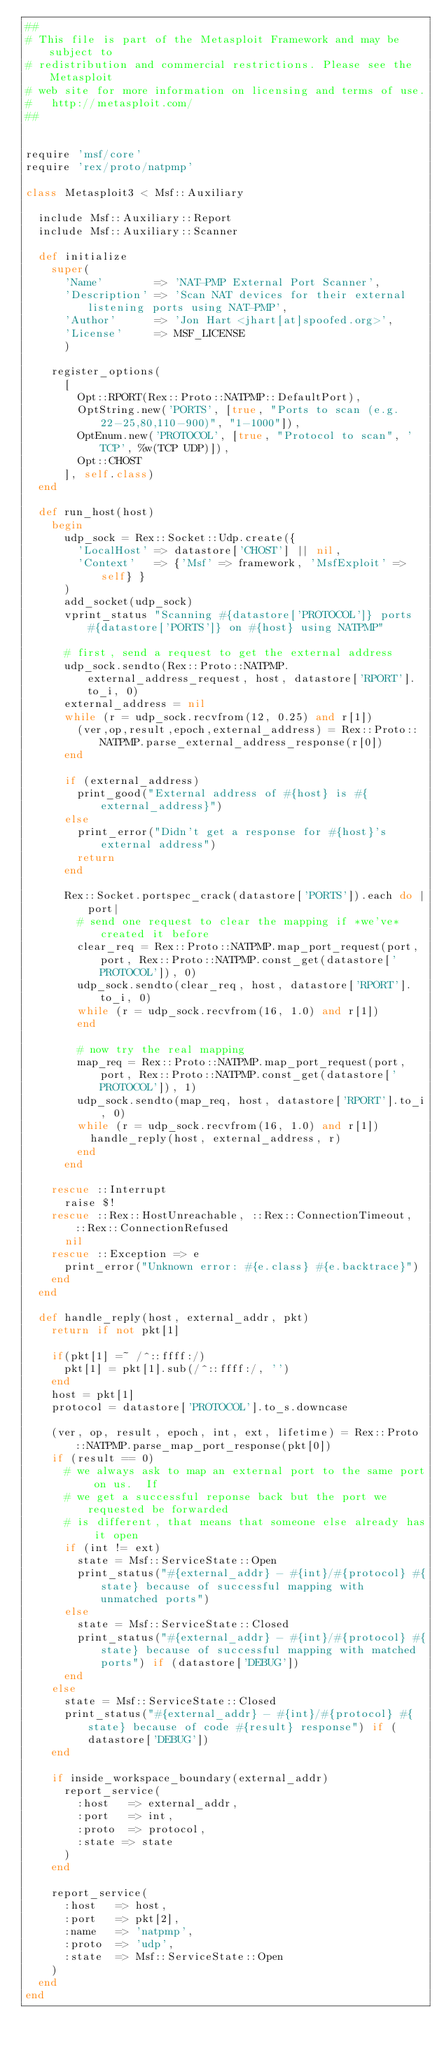Convert code to text. <code><loc_0><loc_0><loc_500><loc_500><_Ruby_>##
# This file is part of the Metasploit Framework and may be subject to
# redistribution and commercial restrictions. Please see the Metasploit
# web site for more information on licensing and terms of use.
#   http://metasploit.com/
##


require 'msf/core'
require 'rex/proto/natpmp'

class Metasploit3 < Msf::Auxiliary

	include Msf::Auxiliary::Report
	include Msf::Auxiliary::Scanner

	def initialize
		super(
			'Name'        => 'NAT-PMP External Port Scanner',
			'Description' => 'Scan NAT devices for their external listening ports using NAT-PMP',
			'Author'      => 'Jon Hart <jhart[at]spoofed.org>',
			'License'     => MSF_LICENSE
			)

		register_options(
			[
				Opt::RPORT(Rex::Proto::NATPMP::DefaultPort),
				OptString.new('PORTS', [true, "Ports to scan (e.g. 22-25,80,110-900)", "1-1000"]),
				OptEnum.new('PROTOCOL', [true, "Protocol to scan", 'TCP', %w(TCP UDP)]),
				Opt::CHOST
			], self.class)
	end

	def run_host(host)
		begin
			udp_sock = Rex::Socket::Udp.create({
				'LocalHost' => datastore['CHOST'] || nil,
				'Context'   => {'Msf' => framework, 'MsfExploit' => self} }
			)
			add_socket(udp_sock)
			vprint_status "Scanning #{datastore['PROTOCOL']} ports #{datastore['PORTS']} on #{host} using NATPMP"

			# first, send a request to get the external address
			udp_sock.sendto(Rex::Proto::NATPMP.external_address_request, host, datastore['RPORT'].to_i, 0)
			external_address = nil
			while (r = udp_sock.recvfrom(12, 0.25) and r[1])
				(ver,op,result,epoch,external_address) = Rex::Proto::NATPMP.parse_external_address_response(r[0])
			end

			if (external_address)
				print_good("External address of #{host} is #{external_address}")
			else
				print_error("Didn't get a response for #{host}'s external address")
				return
			end

			Rex::Socket.portspec_crack(datastore['PORTS']).each do |port|
				# send one request to clear the mapping if *we've* created it before
				clear_req = Rex::Proto::NATPMP.map_port_request(port, port, Rex::Proto::NATPMP.const_get(datastore['PROTOCOL']), 0)
				udp_sock.sendto(clear_req, host, datastore['RPORT'].to_i, 0)
				while (r = udp_sock.recvfrom(16, 1.0) and r[1])
				end

				# now try the real mapping
				map_req = Rex::Proto::NATPMP.map_port_request(port, port, Rex::Proto::NATPMP.const_get(datastore['PROTOCOL']), 1)
				udp_sock.sendto(map_req, host, datastore['RPORT'].to_i, 0)
				while (r = udp_sock.recvfrom(16, 1.0) and r[1])
					handle_reply(host, external_address, r)
				end
			end

		rescue ::Interrupt
			raise $!
		rescue ::Rex::HostUnreachable, ::Rex::ConnectionTimeout, ::Rex::ConnectionRefused
			nil
		rescue ::Exception => e
			print_error("Unknown error: #{e.class} #{e.backtrace}")
		end
	end

	def handle_reply(host, external_addr, pkt)
		return if not pkt[1]

		if(pkt[1] =~ /^::ffff:/)
			pkt[1] = pkt[1].sub(/^::ffff:/, '')
		end
		host = pkt[1]
		protocol = datastore['PROTOCOL'].to_s.downcase

		(ver, op, result, epoch, int, ext, lifetime) = Rex::Proto::NATPMP.parse_map_port_response(pkt[0])
		if (result == 0)
			# we always ask to map an external port to the same port on us.  If
			# we get a successful reponse back but the port we requested be forwarded
			# is different, that means that someone else already has it open
			if (int != ext)
				state = Msf::ServiceState::Open
				print_status("#{external_addr} - #{int}/#{protocol} #{state} because of successful mapping with unmatched ports")
			else
				state = Msf::ServiceState::Closed
				print_status("#{external_addr} - #{int}/#{protocol} #{state} because of successful mapping with matched ports") if (datastore['DEBUG'])
			end
		else
			state = Msf::ServiceState::Closed
			print_status("#{external_addr} - #{int}/#{protocol} #{state} because of code #{result} response") if (datastore['DEBUG'])
		end

		if inside_workspace_boundary(external_addr)
			report_service(
				:host   => external_addr,
				:port   => int,
				:proto  => protocol,
				:state => state
			)
		end

		report_service(
			:host 	=> host,
			:port 	=> pkt[2],
			:name 	=> 'natpmp',
			:proto 	=> 'udp',
			:state	=> Msf::ServiceState::Open
		)
	end
end
</code> 